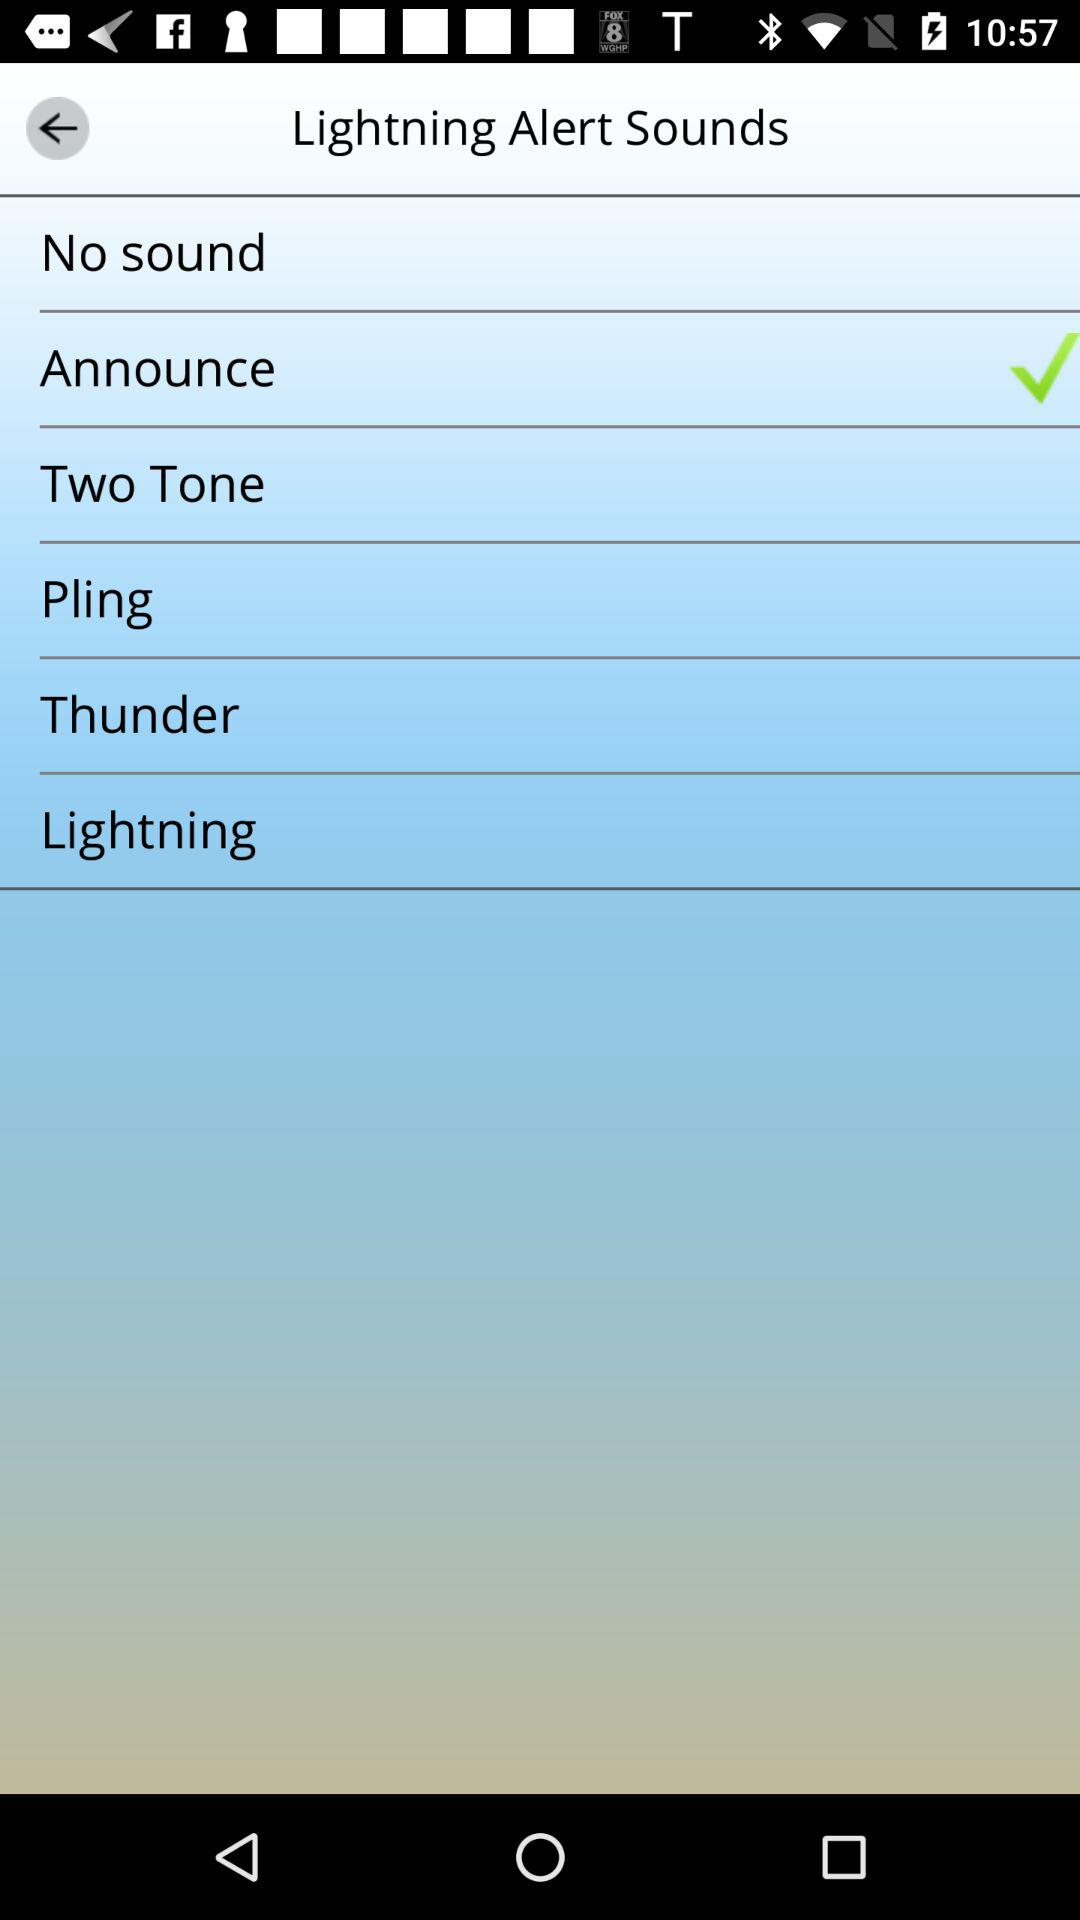Is the Thunder alert sound selected?
When the provided information is insufficient, respond with <no answer>. <no answer> 